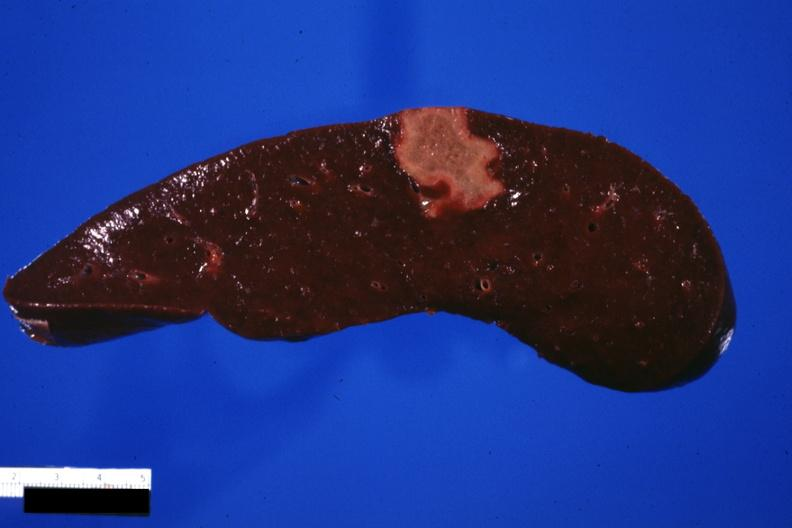s hematologic present?
Answer the question using a single word or phrase. Yes 